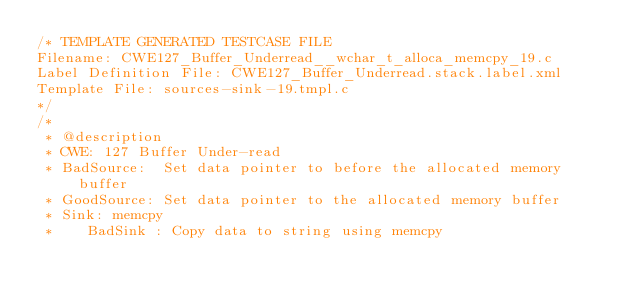<code> <loc_0><loc_0><loc_500><loc_500><_C_>/* TEMPLATE GENERATED TESTCASE FILE
Filename: CWE127_Buffer_Underread__wchar_t_alloca_memcpy_19.c
Label Definition File: CWE127_Buffer_Underread.stack.label.xml
Template File: sources-sink-19.tmpl.c
*/
/*
 * @description
 * CWE: 127 Buffer Under-read
 * BadSource:  Set data pointer to before the allocated memory buffer
 * GoodSource: Set data pointer to the allocated memory buffer
 * Sink: memcpy
 *    BadSink : Copy data to string using memcpy</code> 